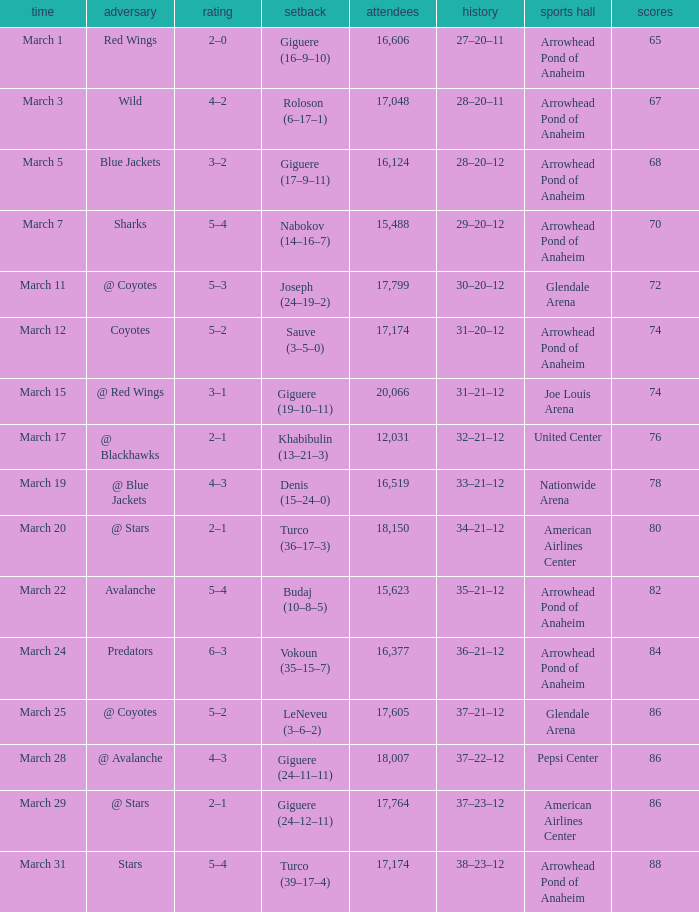What is the Record of the game with an Attendance of more than 16,124 and a Score of 6–3? 36–21–12. 